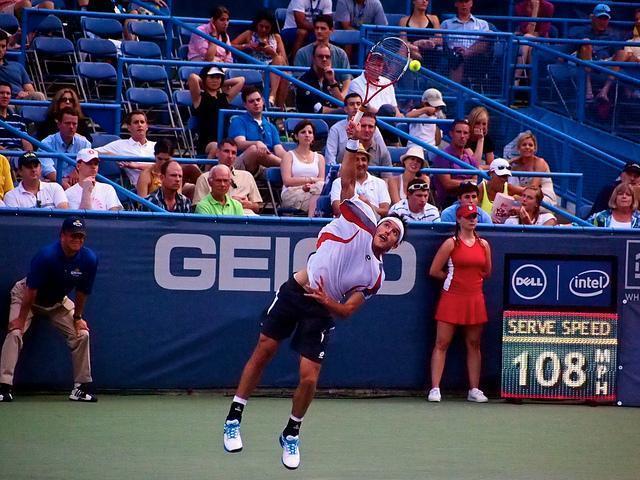How many people are in the photo?
Give a very brief answer. 9. How many sheep are there?
Give a very brief answer. 0. 